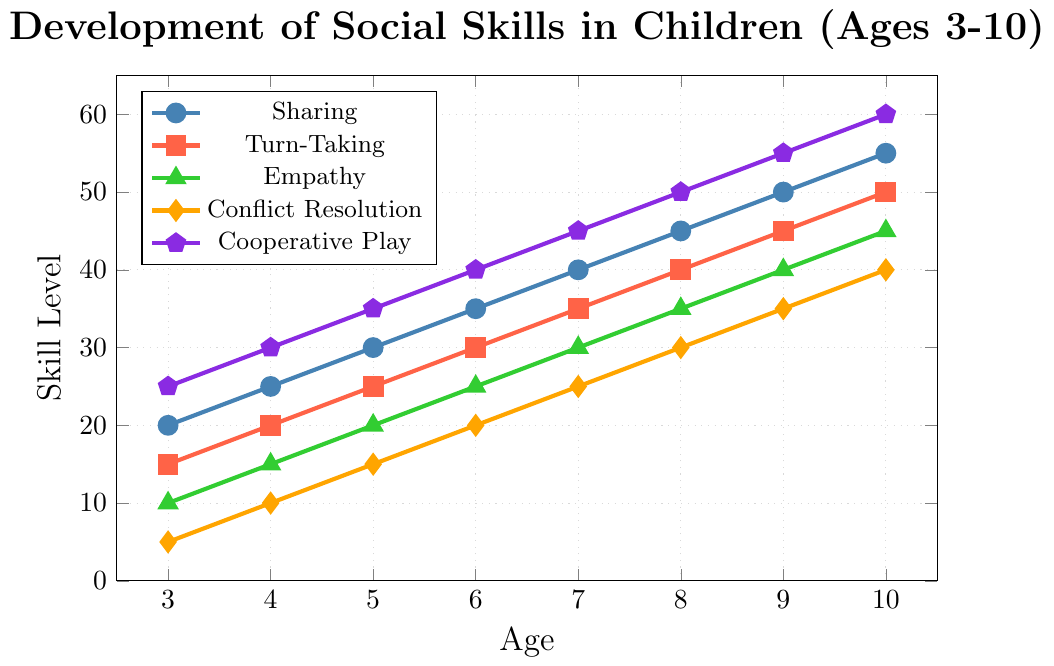What's the overall trend for Empathy from ages 3 to 10? The line for Empathy shows an upward trend from age 3 to age 10, indicating a consistent increase in Empathy scores over time.
Answer: Increasing Which social skill has the steepest initial increase from ages 3 to 4? To find this, compare the increase in each skill from age 3 to 4: Sharing increases by 5, Turn-Taking by 5, Empathy by 5, Conflict Resolution by 5, and Cooperative Play by 5. Since they all increase equally, no single skill has a steeper initial increase.
Answer: All equal Between ages 7 and 10, which skill shows the greatest total increase? Calculate the increase for each skill from age 7 to 10: Sharing (55-40 = 15), Turn-Taking (50-35=15), Empathy (45-30=15), Conflict Resolution (40-25=15), Cooperative Play (60-45=15).
Answer: All equal At age 6, which skill has the lowest level? At age 6, Conflict Resolution has the lowest level with a score of 20.
Answer: Conflict Resolution At what age does Cooperative Play first reach a level of 50? Cooperative Play reaches a level of 50 at age 8.
Answer: Age 8 Compare the levels of Sharing and Empathy at age 5. Which is higher and by how much? At age 5, Sharing has a level of 30 and Empathy has a level of 20. Sharing is higher by 10 points.
Answer: Sharing by 10 What is the average level of Turn-Taking from ages 3 to 6? Calculate the average by summing the levels at ages 3 to 6: (15 + 20 + 25 + 30) / 4 = 90 / 4 = 22.5
Answer: 22.5 If you sum the levels of all social skills at age 4, what do you get? Add the levels at age 4: Sharing (25) + Turn-Taking (20) + Empathy (15) + Conflict Resolution (10) + Cooperative Play (30) = 100
Answer: 100 At what age do Sharing and Cooperative Play reach the same level, and what is that level? Examine the plot to find the intersection point where Sharing and Cooperative Play levels are equal. This occurs at age 3 with a level of 25.
Answer: Age 3, 25 From the plot, which skill shows a uniform increase across all age ranges? All skills (Sharing, Turn-Taking, Empathy, Conflict Resolution, and Cooperative Play) show a uniform increase as their respective lines have consistent slopes.
Answer: All 